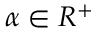<formula> <loc_0><loc_0><loc_500><loc_500>\alpha \in R ^ { + }</formula> 